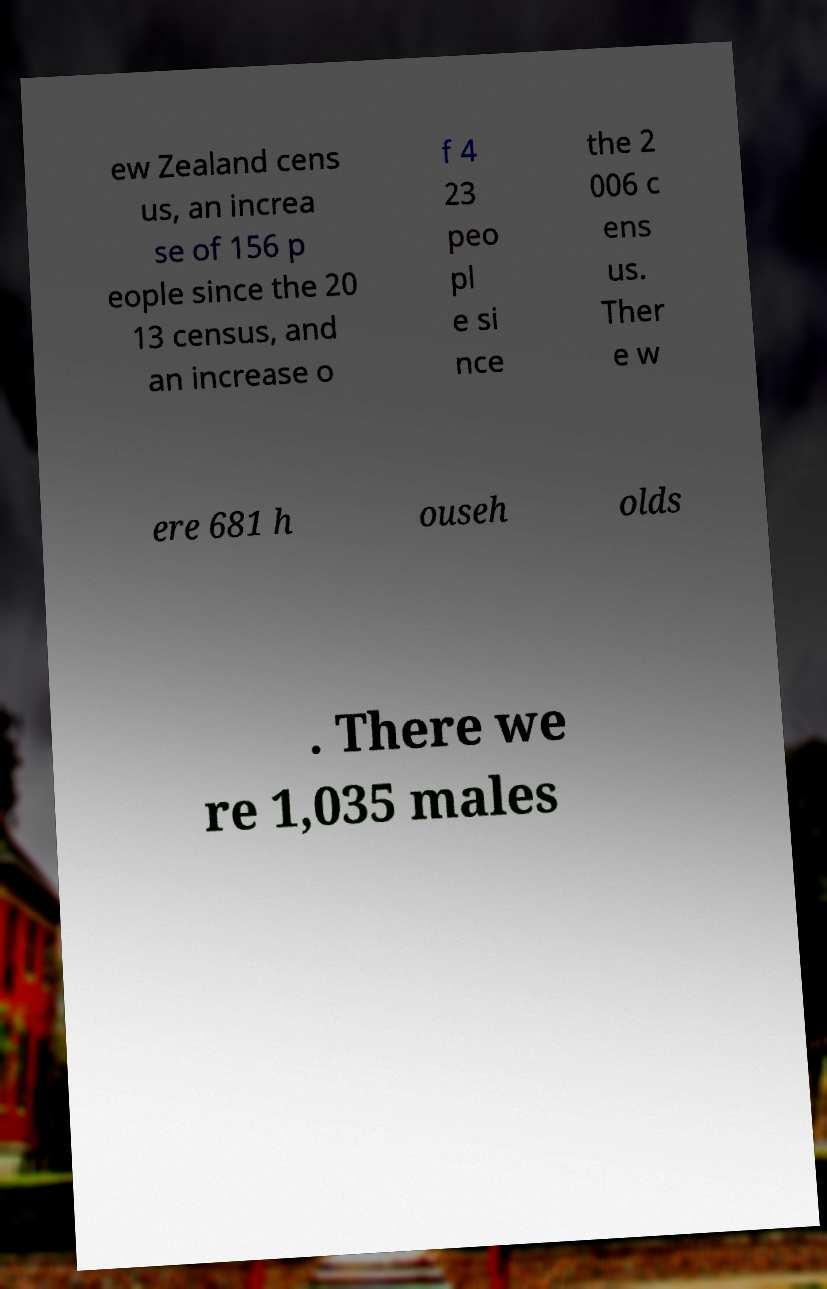Can you read and provide the text displayed in the image?This photo seems to have some interesting text. Can you extract and type it out for me? ew Zealand cens us, an increa se of 156 p eople since the 20 13 census, and an increase o f 4 23 peo pl e si nce the 2 006 c ens us. Ther e w ere 681 h ouseh olds . There we re 1,035 males 